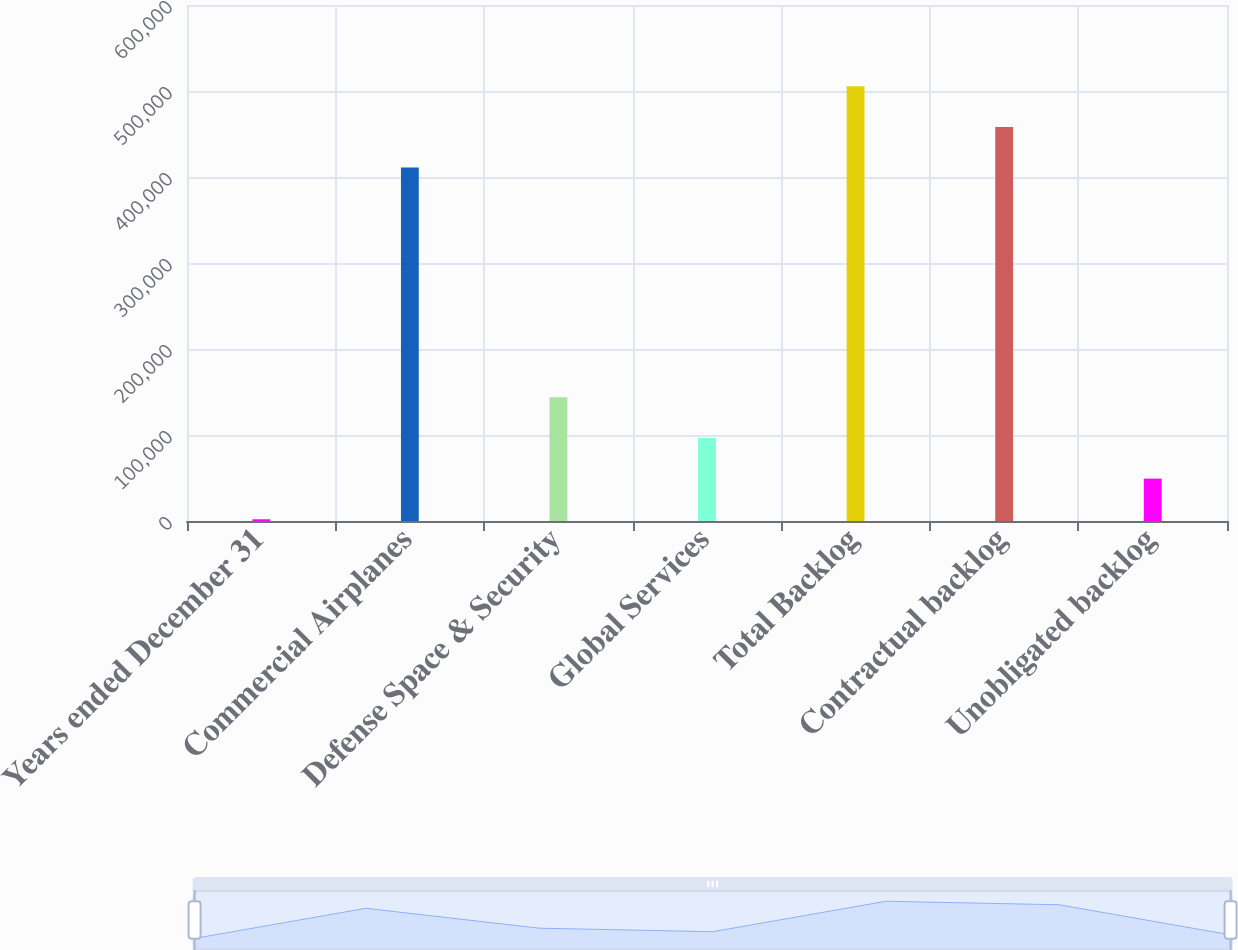<chart> <loc_0><loc_0><loc_500><loc_500><bar_chart><fcel>Years ended December 31<fcel>Commercial Airplanes<fcel>Defense Space & Security<fcel>Global Services<fcel>Total Backlog<fcel>Contractual backlog<fcel>Unobligated backlog<nl><fcel>2017<fcel>410986<fcel>143804<fcel>96541.6<fcel>505511<fcel>458248<fcel>49279.3<nl></chart> 